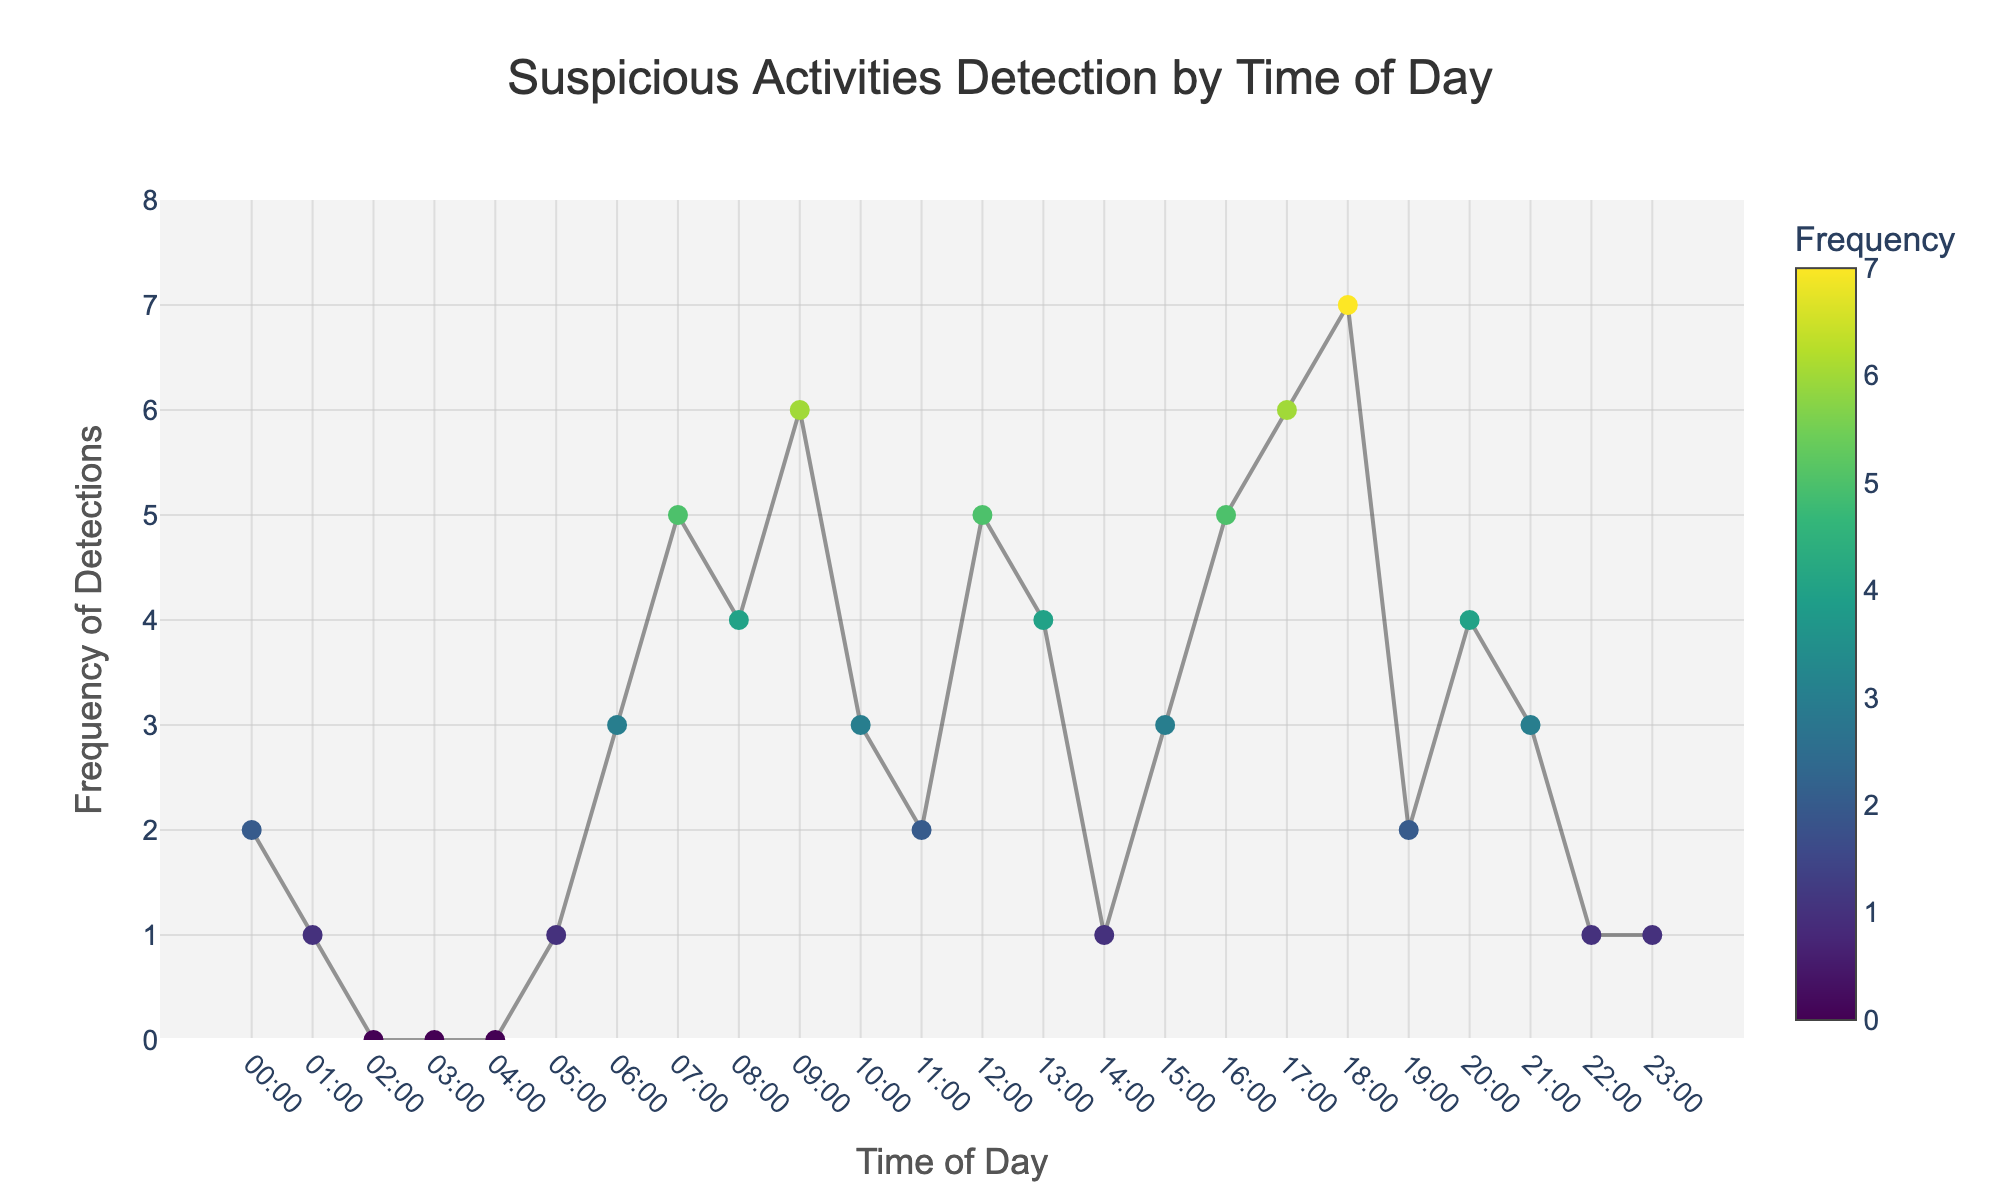What's the title of the figure? The title can be found at the top of the figure. It's often the largest and boldest text.
Answer: Suspicious Activities Detection by Time of Day What's the highest frequency of detections recorded? To determine the highest frequency, look at the y-axis for the maximum value and find the corresponding data point.
Answer: 7 At what time of day were there no detections recorded? Look for data points on the x-axis where the y-value is zero.
Answer: 02:00, 03:00, 04:00 What's the frequency of detections at 09:00? Locate 09:00 on the x-axis and check the corresponding y-value.
Answer: 6 During which time interval is the frequency of detections 5? Identify the data points on the y-axis with a value of 5 and note their corresponding times on the x-axis.
Answer: 07:00, 12:00, 16:00 Compare the frequency of detections at 08:00 and 20:00. Which one is higher? Check the y-values for the times 08:00 and 20:00 and compare.
Answer: 08:00 has a higher frequency How does the frequency of detections change from 18:00 to 19:00? Look at the data points for 18:00 and 19:00 and note the change in y-values.
Answer: Decreases What's the average frequency of detections between 17:00 and 19:00? Sum the frequencies from 17:00, 18:00, and 19:00 and divide by the number of points (3). (6 + 7 + 2) / 3 = 15 / 3
Answer: 5 During what time of day is the frequency of detections the most variable? Identify the period with the largest changes in y-values. Observe the data points and compare the variability.
Answer: 06:00 to 09:00 